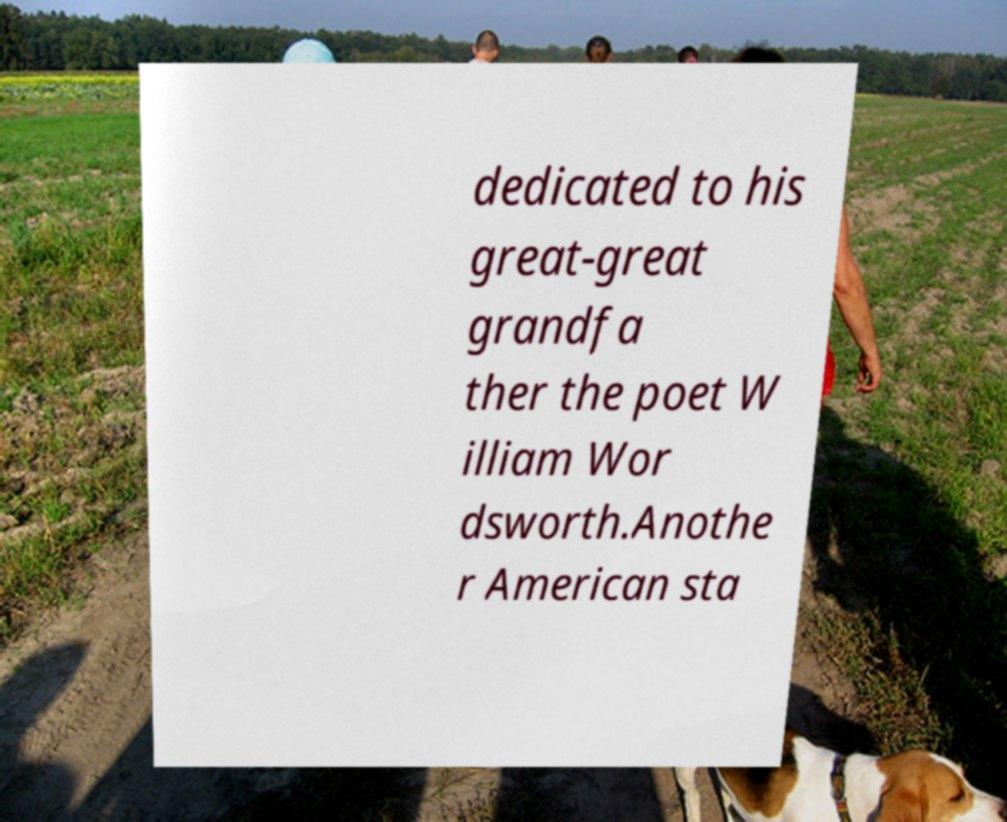What messages or text are displayed in this image? I need them in a readable, typed format. dedicated to his great-great grandfa ther the poet W illiam Wor dsworth.Anothe r American sta 